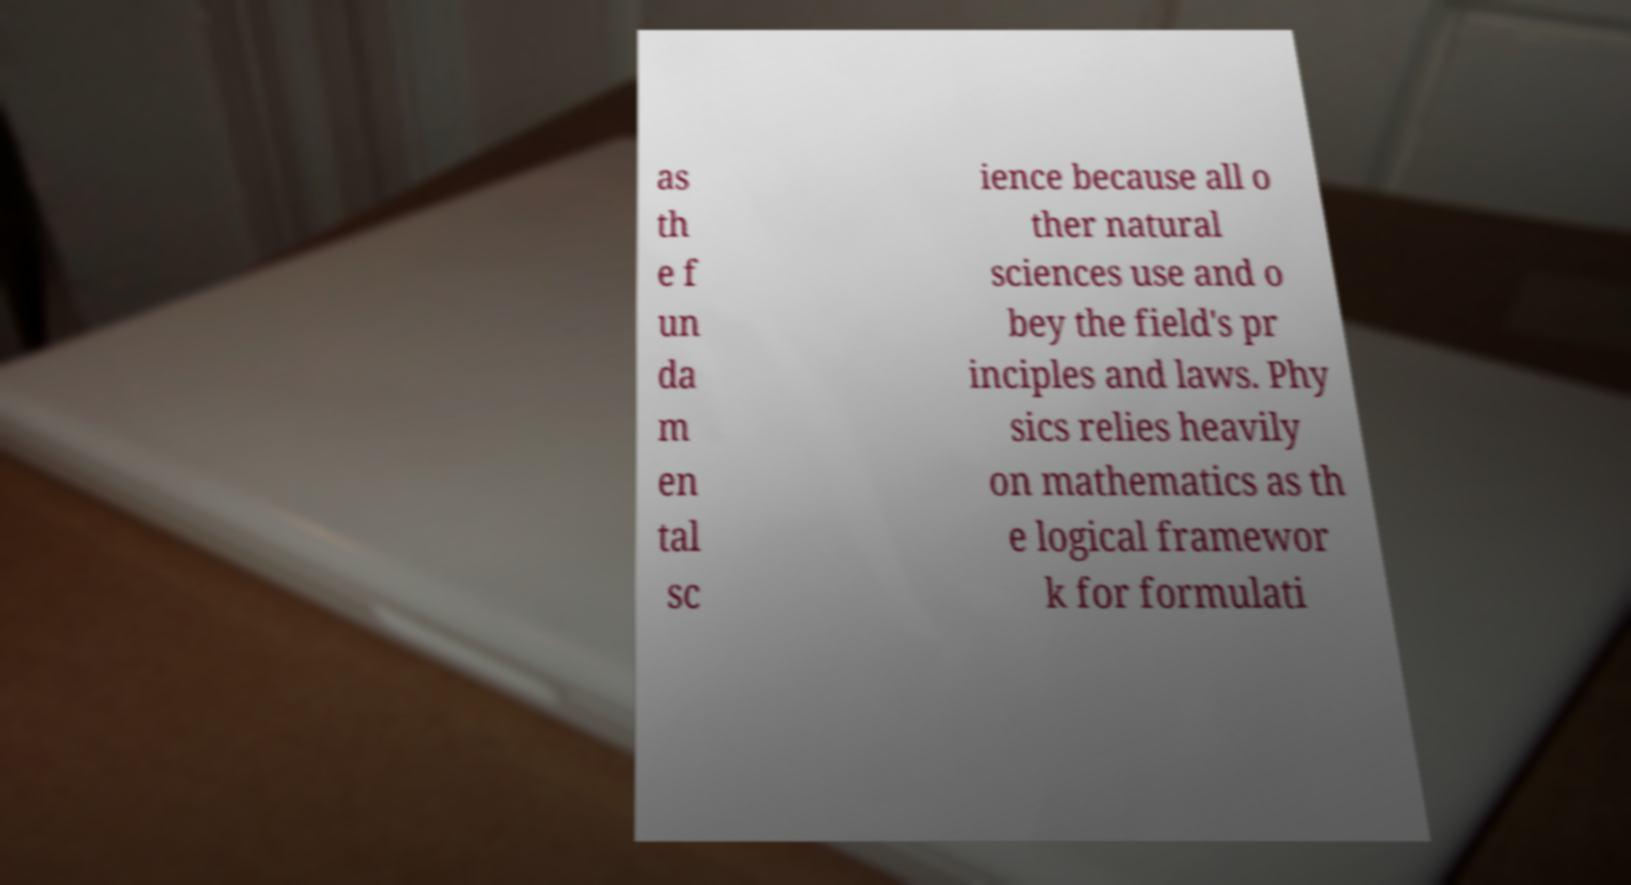Can you read and provide the text displayed in the image?This photo seems to have some interesting text. Can you extract and type it out for me? as th e f un da m en tal sc ience because all o ther natural sciences use and o bey the field's pr inciples and laws. Phy sics relies heavily on mathematics as th e logical framewor k for formulati 